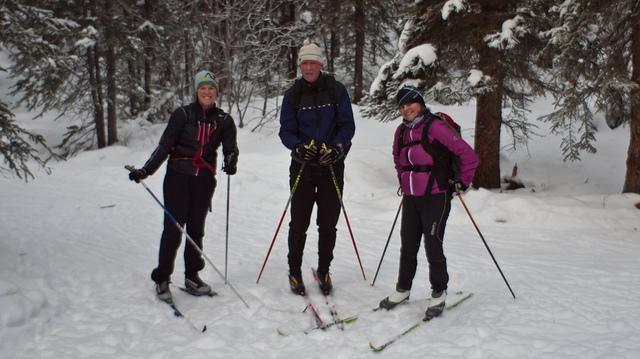How many people are shown?
Give a very brief answer. 3. How many people are there?
Give a very brief answer. 3. 